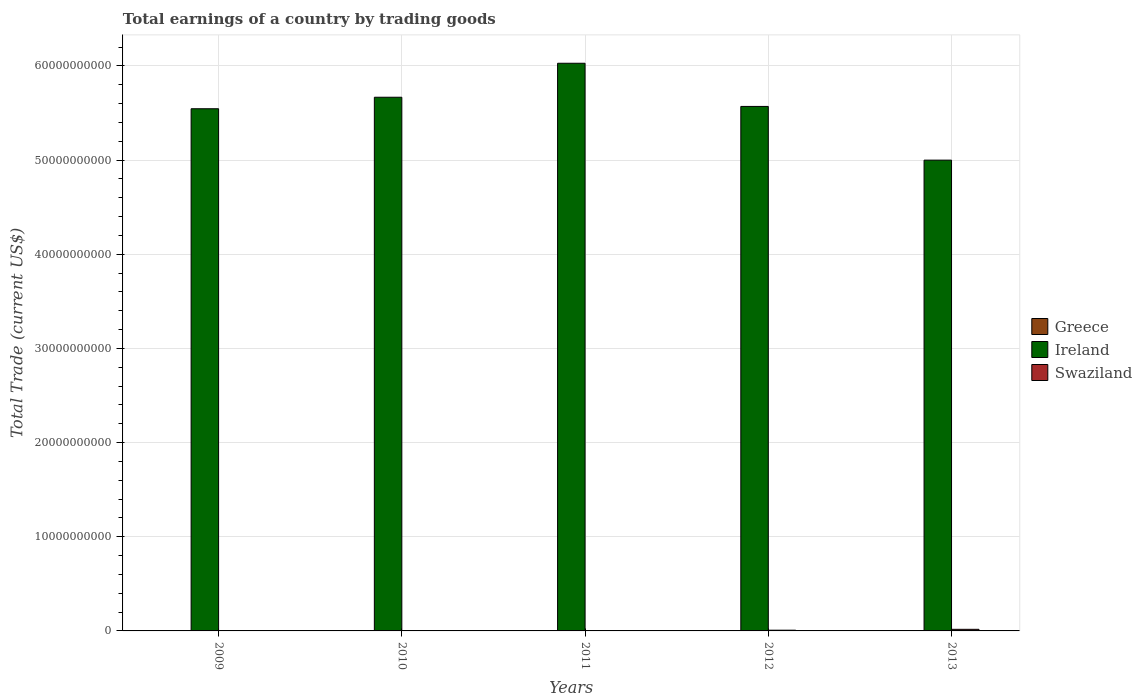How many different coloured bars are there?
Offer a terse response. 2. How many bars are there on the 1st tick from the left?
Provide a succinct answer. 1. How many bars are there on the 2nd tick from the right?
Offer a very short reply. 2. What is the label of the 2nd group of bars from the left?
Provide a short and direct response. 2010. What is the total earnings in Ireland in 2012?
Provide a succinct answer. 5.57e+1. Across all years, what is the maximum total earnings in Swaziland?
Keep it short and to the point. 1.69e+08. In which year was the total earnings in Ireland maximum?
Ensure brevity in your answer.  2011. What is the total total earnings in Ireland in the graph?
Your answer should be very brief. 2.78e+11. What is the difference between the total earnings in Ireland in 2009 and that in 2010?
Offer a terse response. -1.22e+09. In the year 2013, what is the difference between the total earnings in Swaziland and total earnings in Ireland?
Provide a succinct answer. -4.98e+1. What is the ratio of the total earnings in Ireland in 2009 to that in 2012?
Your answer should be very brief. 1. Is the total earnings in Ireland in 2009 less than that in 2012?
Offer a terse response. Yes. What is the difference between the highest and the second highest total earnings in Ireland?
Provide a short and direct response. 3.61e+09. What is the difference between the highest and the lowest total earnings in Ireland?
Ensure brevity in your answer.  1.03e+1. How many bars are there?
Your response must be concise. 7. How many years are there in the graph?
Make the answer very short. 5. Are the values on the major ticks of Y-axis written in scientific E-notation?
Your response must be concise. No. Does the graph contain any zero values?
Ensure brevity in your answer.  Yes. Does the graph contain grids?
Provide a succinct answer. Yes. How are the legend labels stacked?
Your answer should be compact. Vertical. What is the title of the graph?
Offer a terse response. Total earnings of a country by trading goods. Does "Bolivia" appear as one of the legend labels in the graph?
Your answer should be compact. No. What is the label or title of the Y-axis?
Your response must be concise. Total Trade (current US$). What is the Total Trade (current US$) in Greece in 2009?
Keep it short and to the point. 0. What is the Total Trade (current US$) of Ireland in 2009?
Give a very brief answer. 5.54e+1. What is the Total Trade (current US$) of Swaziland in 2009?
Ensure brevity in your answer.  0. What is the Total Trade (current US$) in Ireland in 2010?
Ensure brevity in your answer.  5.67e+1. What is the Total Trade (current US$) in Swaziland in 2010?
Your answer should be very brief. 0. What is the Total Trade (current US$) in Greece in 2011?
Keep it short and to the point. 0. What is the Total Trade (current US$) in Ireland in 2011?
Provide a short and direct response. 6.03e+1. What is the Total Trade (current US$) of Greece in 2012?
Offer a terse response. 0. What is the Total Trade (current US$) of Ireland in 2012?
Make the answer very short. 5.57e+1. What is the Total Trade (current US$) of Swaziland in 2012?
Give a very brief answer. 7.79e+07. What is the Total Trade (current US$) in Ireland in 2013?
Provide a short and direct response. 5.00e+1. What is the Total Trade (current US$) of Swaziland in 2013?
Provide a succinct answer. 1.69e+08. Across all years, what is the maximum Total Trade (current US$) of Ireland?
Offer a terse response. 6.03e+1. Across all years, what is the maximum Total Trade (current US$) in Swaziland?
Your answer should be very brief. 1.69e+08. Across all years, what is the minimum Total Trade (current US$) in Ireland?
Your answer should be compact. 5.00e+1. Across all years, what is the minimum Total Trade (current US$) in Swaziland?
Ensure brevity in your answer.  0. What is the total Total Trade (current US$) of Ireland in the graph?
Your answer should be very brief. 2.78e+11. What is the total Total Trade (current US$) in Swaziland in the graph?
Offer a terse response. 2.47e+08. What is the difference between the Total Trade (current US$) of Ireland in 2009 and that in 2010?
Give a very brief answer. -1.22e+09. What is the difference between the Total Trade (current US$) in Ireland in 2009 and that in 2011?
Your answer should be compact. -4.83e+09. What is the difference between the Total Trade (current US$) in Ireland in 2009 and that in 2012?
Make the answer very short. -2.46e+08. What is the difference between the Total Trade (current US$) in Ireland in 2009 and that in 2013?
Offer a terse response. 5.46e+09. What is the difference between the Total Trade (current US$) of Ireland in 2010 and that in 2011?
Offer a very short reply. -3.61e+09. What is the difference between the Total Trade (current US$) of Ireland in 2010 and that in 2012?
Your answer should be compact. 9.75e+08. What is the difference between the Total Trade (current US$) in Ireland in 2010 and that in 2013?
Your answer should be very brief. 6.68e+09. What is the difference between the Total Trade (current US$) in Ireland in 2011 and that in 2012?
Keep it short and to the point. 4.58e+09. What is the difference between the Total Trade (current US$) in Ireland in 2011 and that in 2013?
Provide a succinct answer. 1.03e+1. What is the difference between the Total Trade (current US$) of Ireland in 2012 and that in 2013?
Your response must be concise. 5.70e+09. What is the difference between the Total Trade (current US$) in Swaziland in 2012 and that in 2013?
Provide a succinct answer. -9.15e+07. What is the difference between the Total Trade (current US$) in Ireland in 2009 and the Total Trade (current US$) in Swaziland in 2012?
Keep it short and to the point. 5.54e+1. What is the difference between the Total Trade (current US$) of Ireland in 2009 and the Total Trade (current US$) of Swaziland in 2013?
Ensure brevity in your answer.  5.53e+1. What is the difference between the Total Trade (current US$) in Ireland in 2010 and the Total Trade (current US$) in Swaziland in 2012?
Offer a terse response. 5.66e+1. What is the difference between the Total Trade (current US$) in Ireland in 2010 and the Total Trade (current US$) in Swaziland in 2013?
Make the answer very short. 5.65e+1. What is the difference between the Total Trade (current US$) in Ireland in 2011 and the Total Trade (current US$) in Swaziland in 2012?
Your response must be concise. 6.02e+1. What is the difference between the Total Trade (current US$) in Ireland in 2011 and the Total Trade (current US$) in Swaziland in 2013?
Make the answer very short. 6.01e+1. What is the difference between the Total Trade (current US$) in Ireland in 2012 and the Total Trade (current US$) in Swaziland in 2013?
Keep it short and to the point. 5.55e+1. What is the average Total Trade (current US$) of Ireland per year?
Offer a very short reply. 5.56e+1. What is the average Total Trade (current US$) of Swaziland per year?
Make the answer very short. 4.94e+07. In the year 2012, what is the difference between the Total Trade (current US$) of Ireland and Total Trade (current US$) of Swaziland?
Offer a terse response. 5.56e+1. In the year 2013, what is the difference between the Total Trade (current US$) of Ireland and Total Trade (current US$) of Swaziland?
Provide a succinct answer. 4.98e+1. What is the ratio of the Total Trade (current US$) in Ireland in 2009 to that in 2010?
Make the answer very short. 0.98. What is the ratio of the Total Trade (current US$) in Ireland in 2009 to that in 2011?
Offer a terse response. 0.92. What is the ratio of the Total Trade (current US$) of Ireland in 2009 to that in 2012?
Provide a succinct answer. 1. What is the ratio of the Total Trade (current US$) of Ireland in 2009 to that in 2013?
Offer a very short reply. 1.11. What is the ratio of the Total Trade (current US$) in Ireland in 2010 to that in 2011?
Offer a very short reply. 0.94. What is the ratio of the Total Trade (current US$) of Ireland in 2010 to that in 2012?
Your answer should be compact. 1.02. What is the ratio of the Total Trade (current US$) in Ireland in 2010 to that in 2013?
Your answer should be very brief. 1.13. What is the ratio of the Total Trade (current US$) in Ireland in 2011 to that in 2012?
Give a very brief answer. 1.08. What is the ratio of the Total Trade (current US$) of Ireland in 2011 to that in 2013?
Provide a short and direct response. 1.21. What is the ratio of the Total Trade (current US$) of Ireland in 2012 to that in 2013?
Make the answer very short. 1.11. What is the ratio of the Total Trade (current US$) in Swaziland in 2012 to that in 2013?
Ensure brevity in your answer.  0.46. What is the difference between the highest and the second highest Total Trade (current US$) in Ireland?
Your answer should be compact. 3.61e+09. What is the difference between the highest and the lowest Total Trade (current US$) in Ireland?
Offer a terse response. 1.03e+1. What is the difference between the highest and the lowest Total Trade (current US$) of Swaziland?
Your answer should be compact. 1.69e+08. 